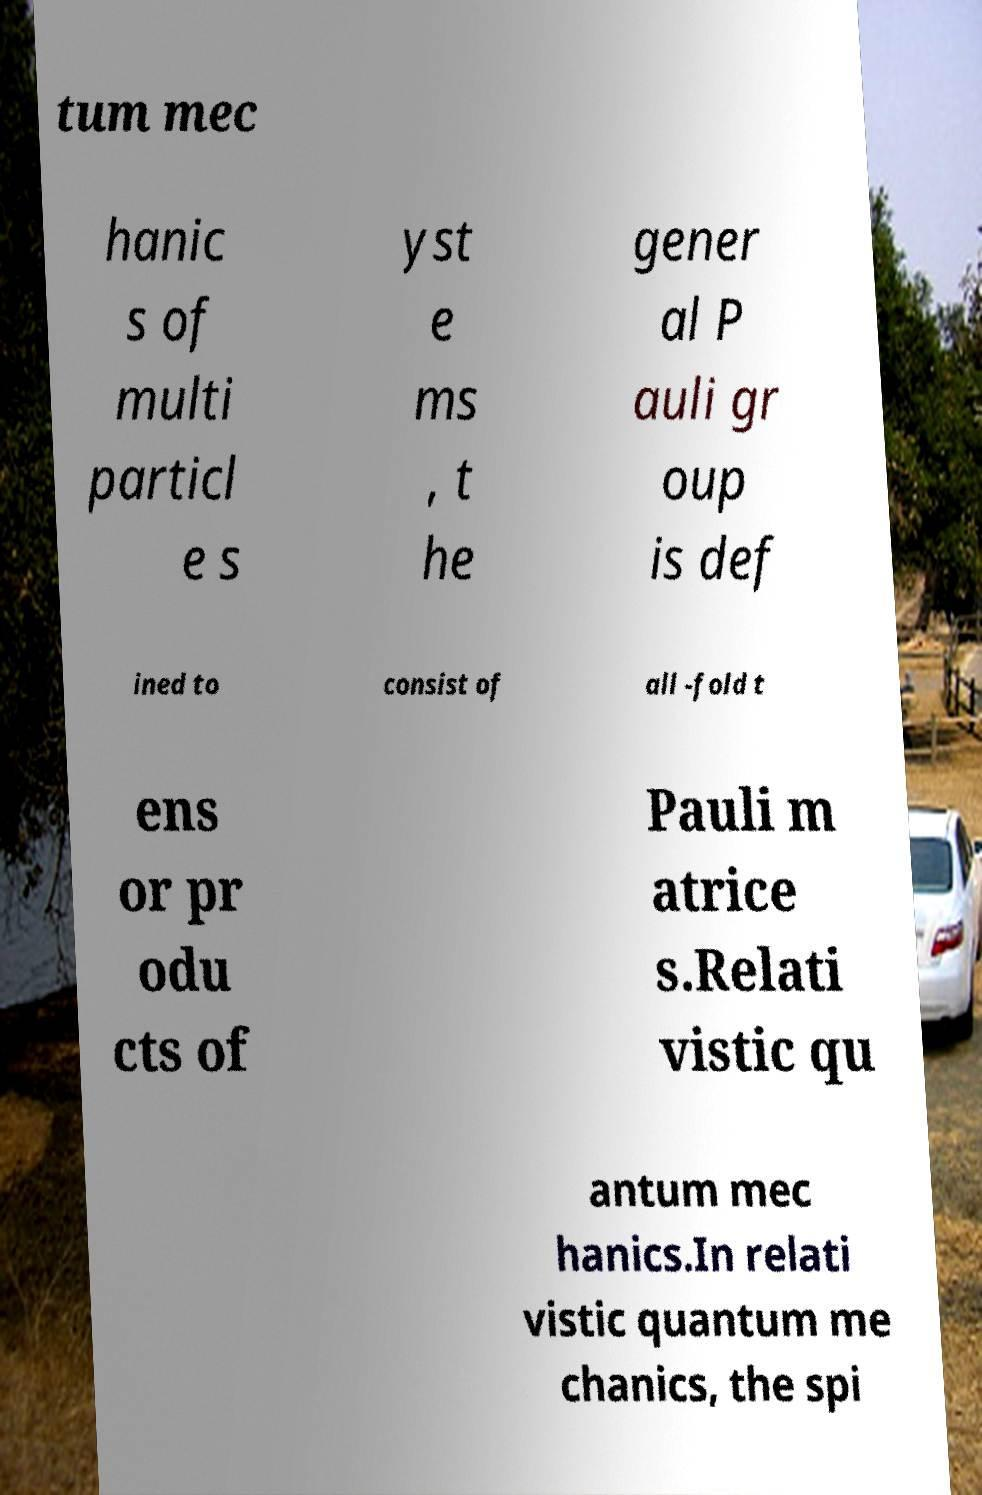Can you accurately transcribe the text from the provided image for me? tum mec hanic s of multi particl e s yst e ms , t he gener al P auli gr oup is def ined to consist of all -fold t ens or pr odu cts of Pauli m atrice s.Relati vistic qu antum mec hanics.In relati vistic quantum me chanics, the spi 